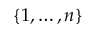<formula> <loc_0><loc_0><loc_500><loc_500>\{ 1 , \dots , n \}</formula> 